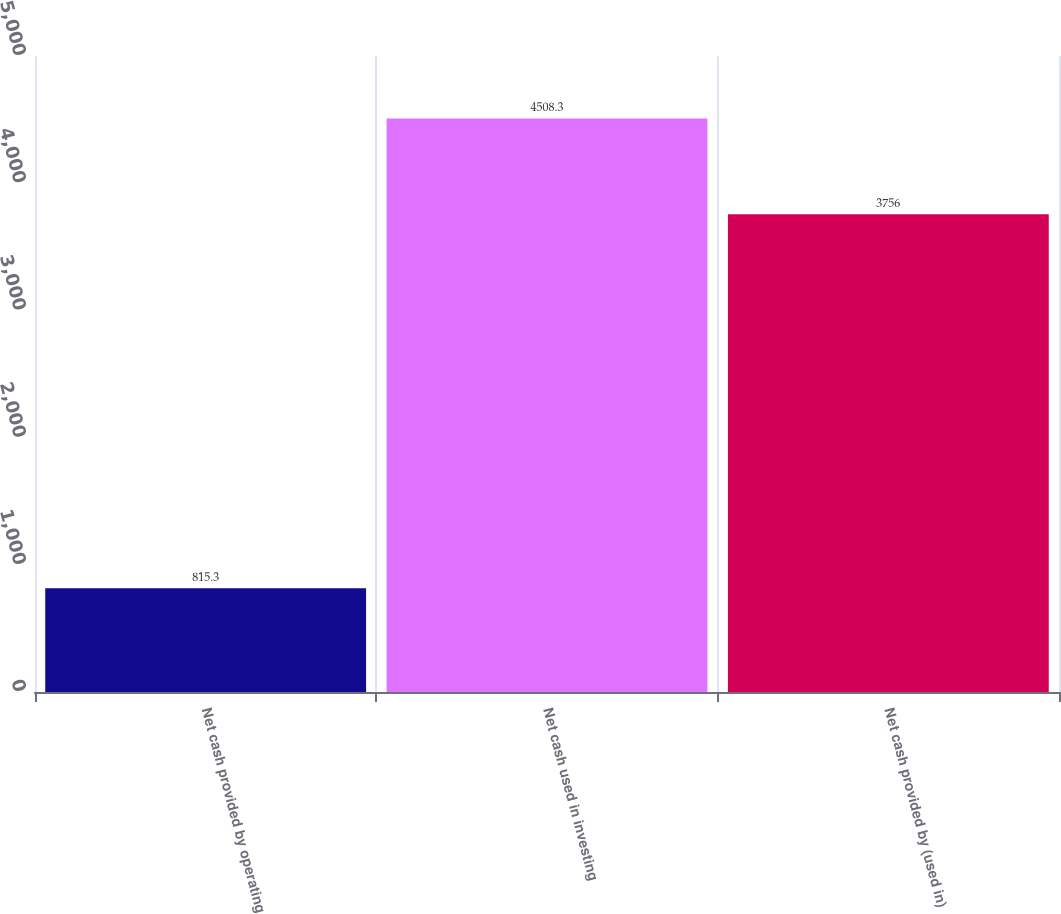Convert chart to OTSL. <chart><loc_0><loc_0><loc_500><loc_500><bar_chart><fcel>Net cash provided by operating<fcel>Net cash used in investing<fcel>Net cash provided by (used in)<nl><fcel>815.3<fcel>4508.3<fcel>3756<nl></chart> 